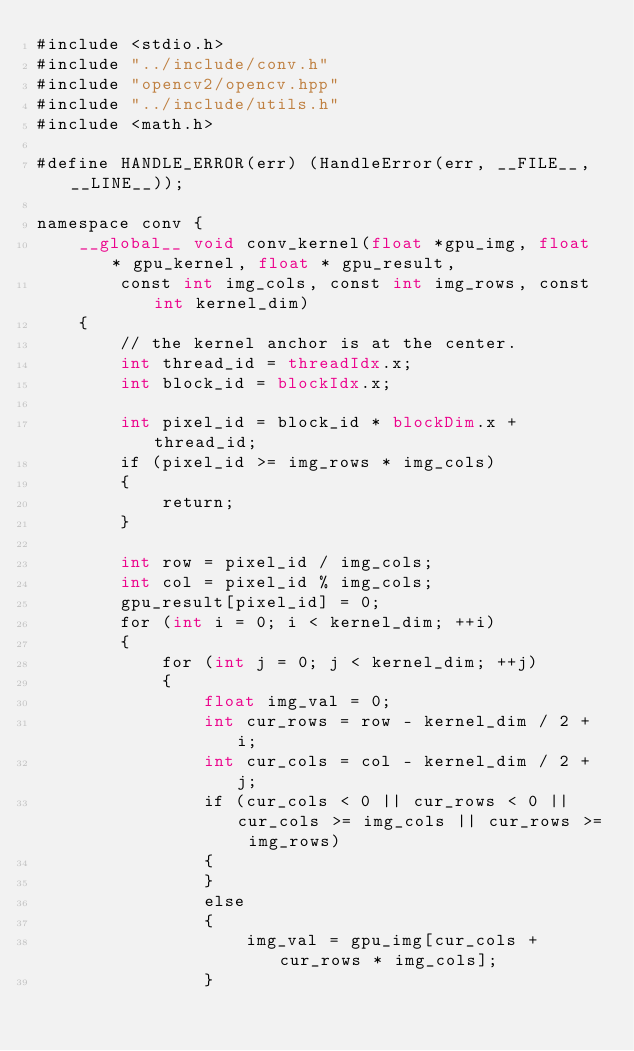<code> <loc_0><loc_0><loc_500><loc_500><_Cuda_>#include <stdio.h>
#include "../include/conv.h"
#include "opencv2/opencv.hpp"
#include "../include/utils.h"
#include <math.h>

#define HANDLE_ERROR(err) (HandleError(err, __FILE__, __LINE__));

namespace conv {
	__global__ void conv_kernel(float *gpu_img, float * gpu_kernel, float * gpu_result,
		const int img_cols, const int img_rows, const int kernel_dim)
	{
		// the kernel anchor is at the center.
		int thread_id = threadIdx.x;
		int block_id = blockIdx.x;

		int pixel_id = block_id * blockDim.x + thread_id;
		if (pixel_id >= img_rows * img_cols)
		{
			return;
		}

		int row = pixel_id / img_cols;
		int col = pixel_id % img_cols;
		gpu_result[pixel_id] = 0;
		for (int i = 0; i < kernel_dim; ++i)
		{
			for (int j = 0; j < kernel_dim; ++j)
			{
				float img_val = 0;
				int cur_rows = row - kernel_dim / 2 + i;
				int cur_cols = col - kernel_dim / 2 + j;
				if (cur_cols < 0 || cur_rows < 0 || cur_cols >= img_cols || cur_rows >= img_rows)
				{
				}
				else
				{
					img_val = gpu_img[cur_cols + cur_rows * img_cols];
				}</code> 